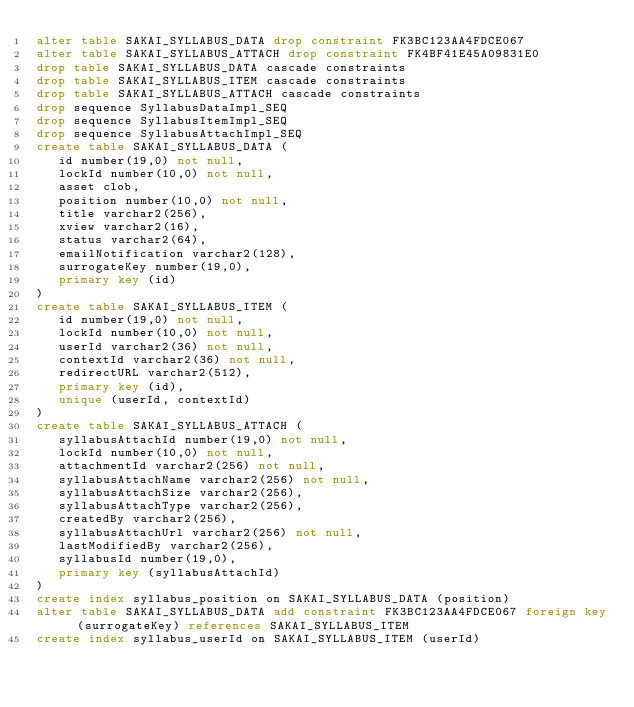Convert code to text. <code><loc_0><loc_0><loc_500><loc_500><_SQL_>alter table SAKAI_SYLLABUS_DATA drop constraint FK3BC123AA4FDCE067
alter table SAKAI_SYLLABUS_ATTACH drop constraint FK4BF41E45A09831E0
drop table SAKAI_SYLLABUS_DATA cascade constraints
drop table SAKAI_SYLLABUS_ITEM cascade constraints
drop table SAKAI_SYLLABUS_ATTACH cascade constraints
drop sequence SyllabusDataImpl_SEQ
drop sequence SyllabusItemImpl_SEQ
drop sequence SyllabusAttachImpl_SEQ
create table SAKAI_SYLLABUS_DATA (
   id number(19,0) not null,
   lockId number(10,0) not null,
   asset clob,
   position number(10,0) not null,
   title varchar2(256),
   xview varchar2(16),
   status varchar2(64),
   emailNotification varchar2(128),
   surrogateKey number(19,0),
   primary key (id)
)
create table SAKAI_SYLLABUS_ITEM (
   id number(19,0) not null,
   lockId number(10,0) not null,
   userId varchar2(36) not null,
   contextId varchar2(36) not null,
   redirectURL varchar2(512),
   primary key (id),
   unique (userId, contextId)
)
create table SAKAI_SYLLABUS_ATTACH (
   syllabusAttachId number(19,0) not null,
   lockId number(10,0) not null,
   attachmentId varchar2(256) not null,
   syllabusAttachName varchar2(256) not null,
   syllabusAttachSize varchar2(256),
   syllabusAttachType varchar2(256),
   createdBy varchar2(256),
   syllabusAttachUrl varchar2(256) not null,
   lastModifiedBy varchar2(256),
   syllabusId number(19,0),
   primary key (syllabusAttachId)
)
create index syllabus_position on SAKAI_SYLLABUS_DATA (position)
alter table SAKAI_SYLLABUS_DATA add constraint FK3BC123AA4FDCE067 foreign key (surrogateKey) references SAKAI_SYLLABUS_ITEM
create index syllabus_userId on SAKAI_SYLLABUS_ITEM (userId)</code> 